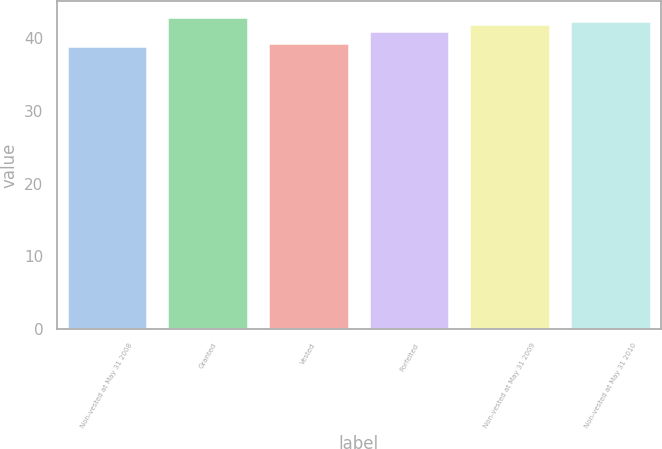Convert chart. <chart><loc_0><loc_0><loc_500><loc_500><bar_chart><fcel>Non-vested at May 31 2008<fcel>Granted<fcel>Vested<fcel>Forfeited<fcel>Non-vested at May 31 2009<fcel>Non-vested at May 31 2010<nl><fcel>39<fcel>43<fcel>39.4<fcel>41<fcel>42<fcel>42.4<nl></chart> 